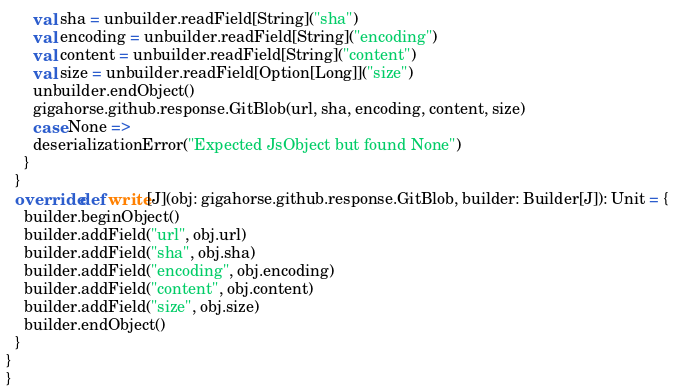<code> <loc_0><loc_0><loc_500><loc_500><_Scala_>      val sha = unbuilder.readField[String]("sha")
      val encoding = unbuilder.readField[String]("encoding")
      val content = unbuilder.readField[String]("content")
      val size = unbuilder.readField[Option[Long]]("size")
      unbuilder.endObject()
      gigahorse.github.response.GitBlob(url, sha, encoding, content, size)
      case None =>
      deserializationError("Expected JsObject but found None")
    }
  }
  override def write[J](obj: gigahorse.github.response.GitBlob, builder: Builder[J]): Unit = {
    builder.beginObject()
    builder.addField("url", obj.url)
    builder.addField("sha", obj.sha)
    builder.addField("encoding", obj.encoding)
    builder.addField("content", obj.content)
    builder.addField("size", obj.size)
    builder.endObject()
  }
}
}
</code> 